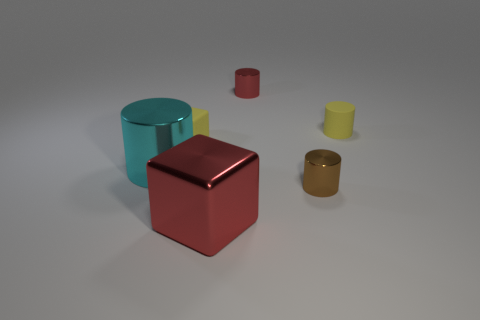Subtract all blue cylinders. Subtract all blue balls. How many cylinders are left? 4 Add 4 tiny blue shiny balls. How many objects exist? 10 Subtract all cylinders. How many objects are left? 2 Add 4 large shiny objects. How many large shiny objects exist? 6 Subtract 0 purple cylinders. How many objects are left? 6 Subtract all cyan shiny cylinders. Subtract all tiny metal cylinders. How many objects are left? 3 Add 1 small red metal cylinders. How many small red metal cylinders are left? 2 